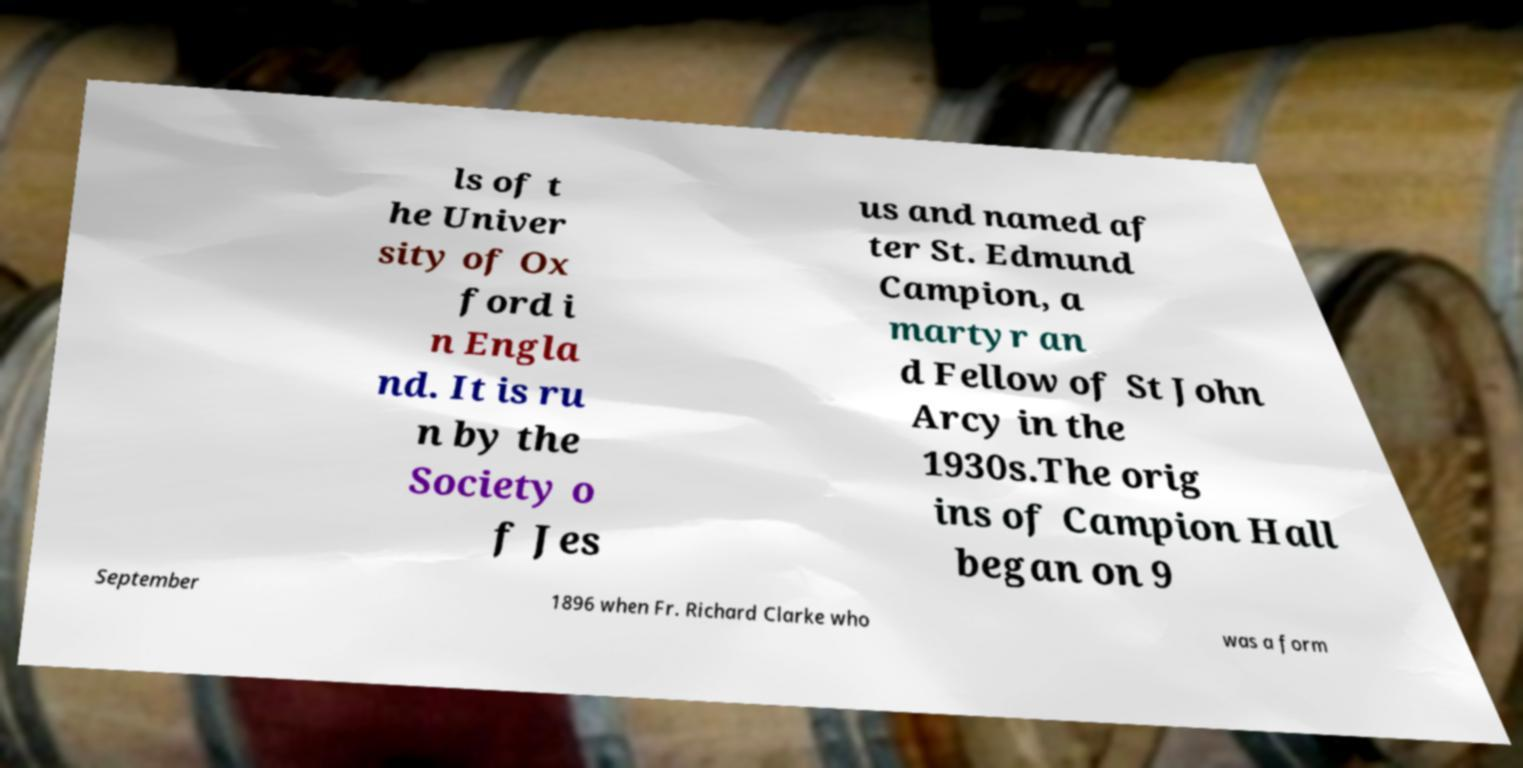Can you accurately transcribe the text from the provided image for me? ls of t he Univer sity of Ox ford i n Engla nd. It is ru n by the Society o f Jes us and named af ter St. Edmund Campion, a martyr an d Fellow of St John Arcy in the 1930s.The orig ins of Campion Hall began on 9 September 1896 when Fr. Richard Clarke who was a form 